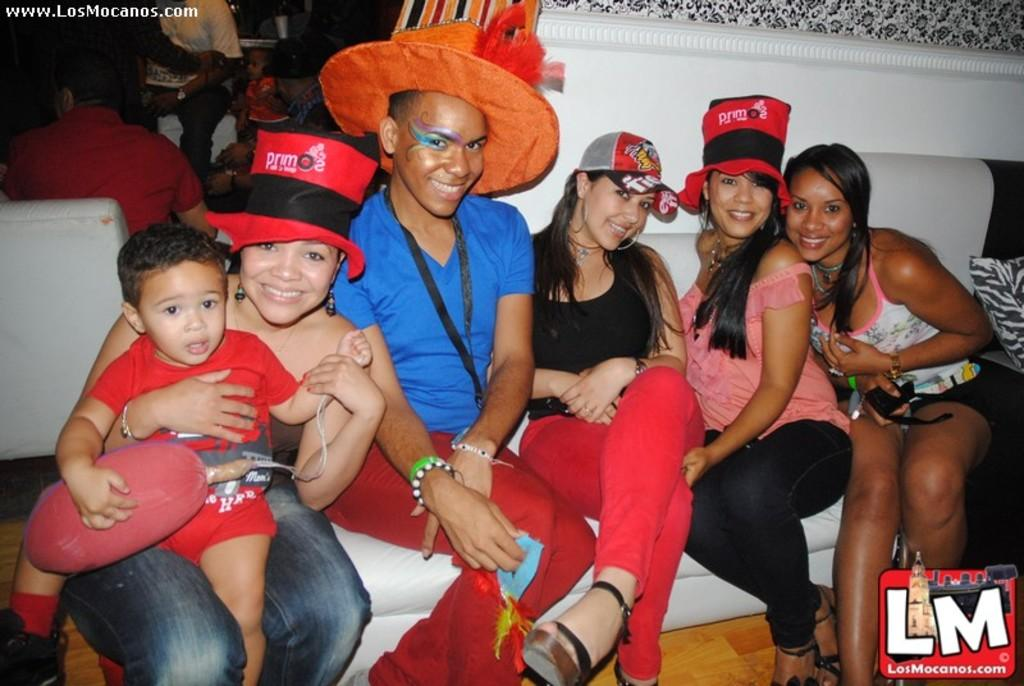Who is present in the image? There are people in the image. What are the people wearing on their heads? The people are wearing hats. Where are the people sitting? The people are seated on a sofa. What expressions do the people have? The people have smiles on their faces. Are there any other individuals in the image? Yes, there are other people in the image. What are the other people sitting on? The other people are seated on chairs. What type of baseball equipment can be seen in the image? There is no baseball equipment present in the image. What color are the teeth of the people in the image? The image does not show the teeth of the people, so it cannot be determined what color they are. 